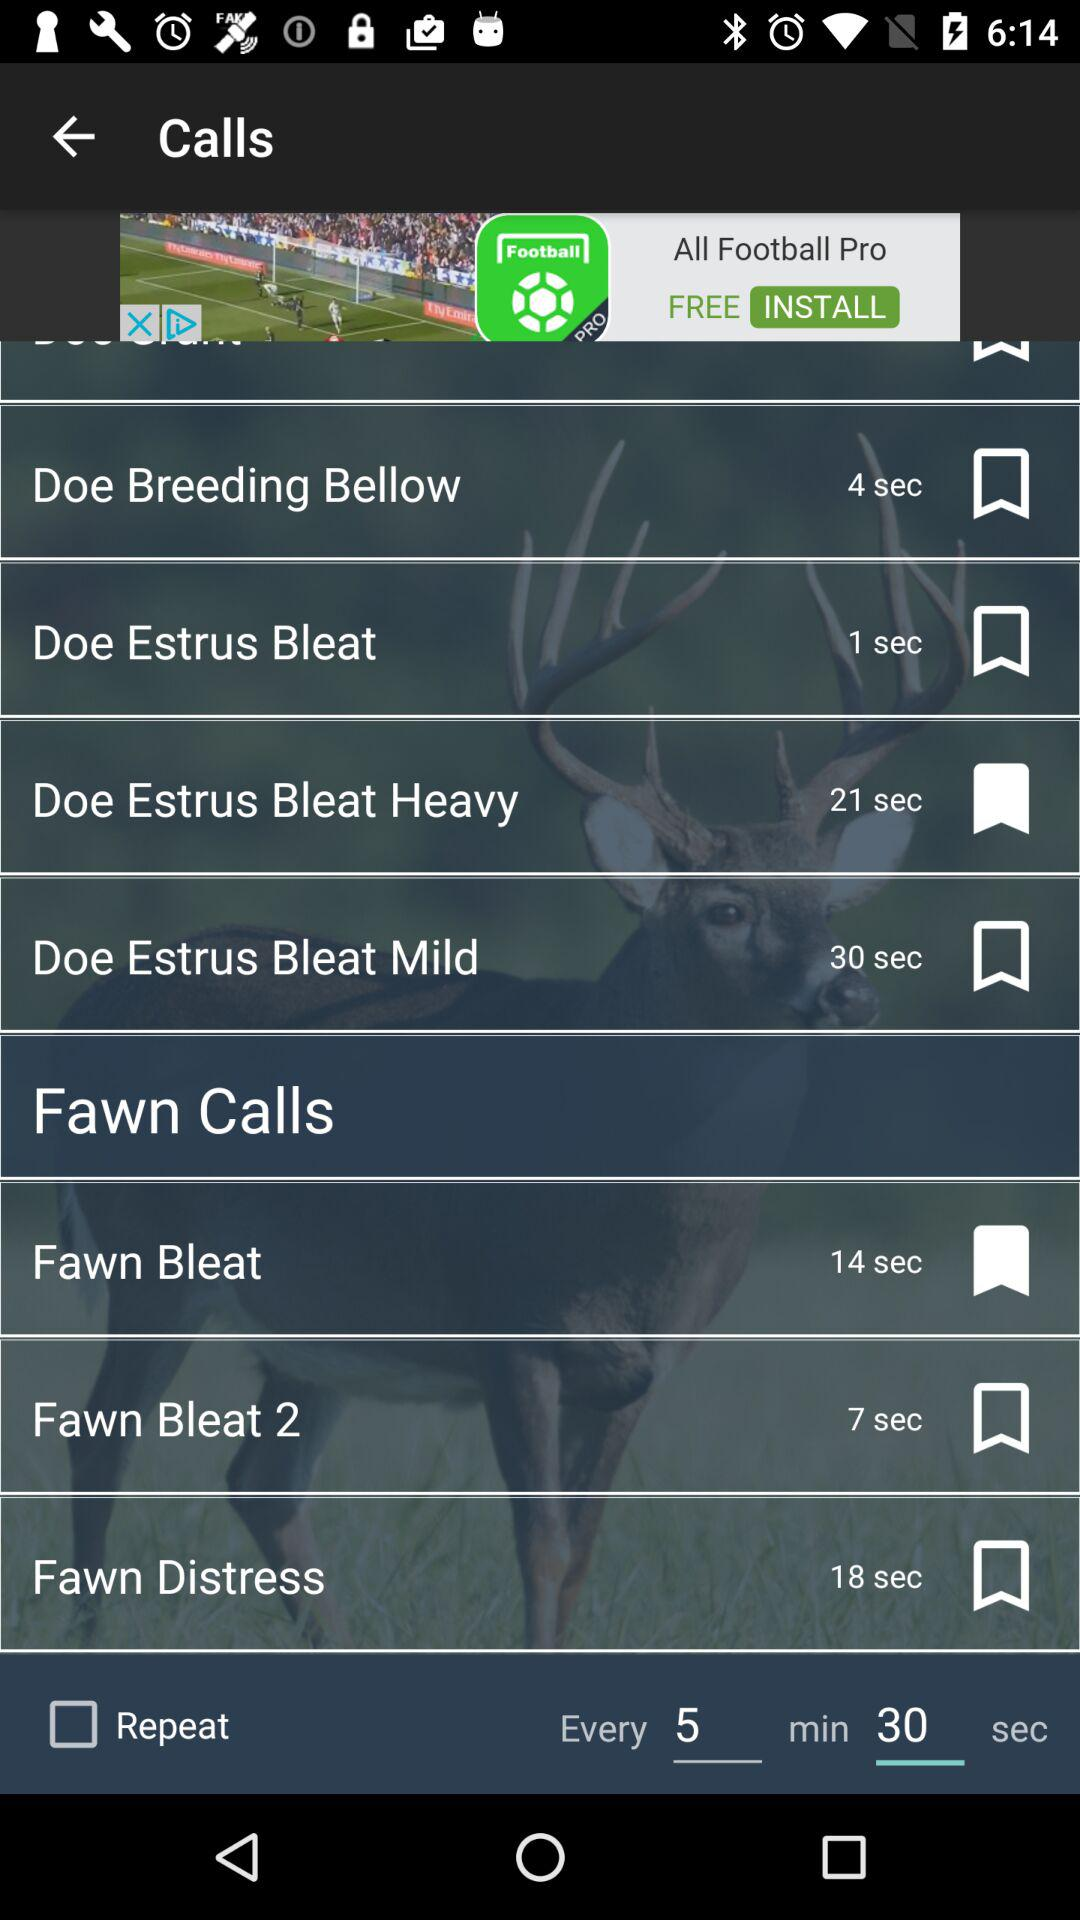Which call has a duration of 18 seconds? The call "Fawn Distress" has a duration of 18 seconds. 